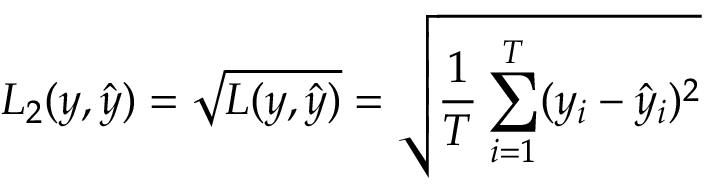<formula> <loc_0><loc_0><loc_500><loc_500>L _ { 2 } ( y , \hat { y } ) = \sqrt { L ( y , \hat { y } ) } = \sqrt { \frac { 1 } { T } \sum _ { i = 1 } ^ { T } ( y _ { i } - \hat { y } _ { i } ) ^ { 2 } }</formula> 